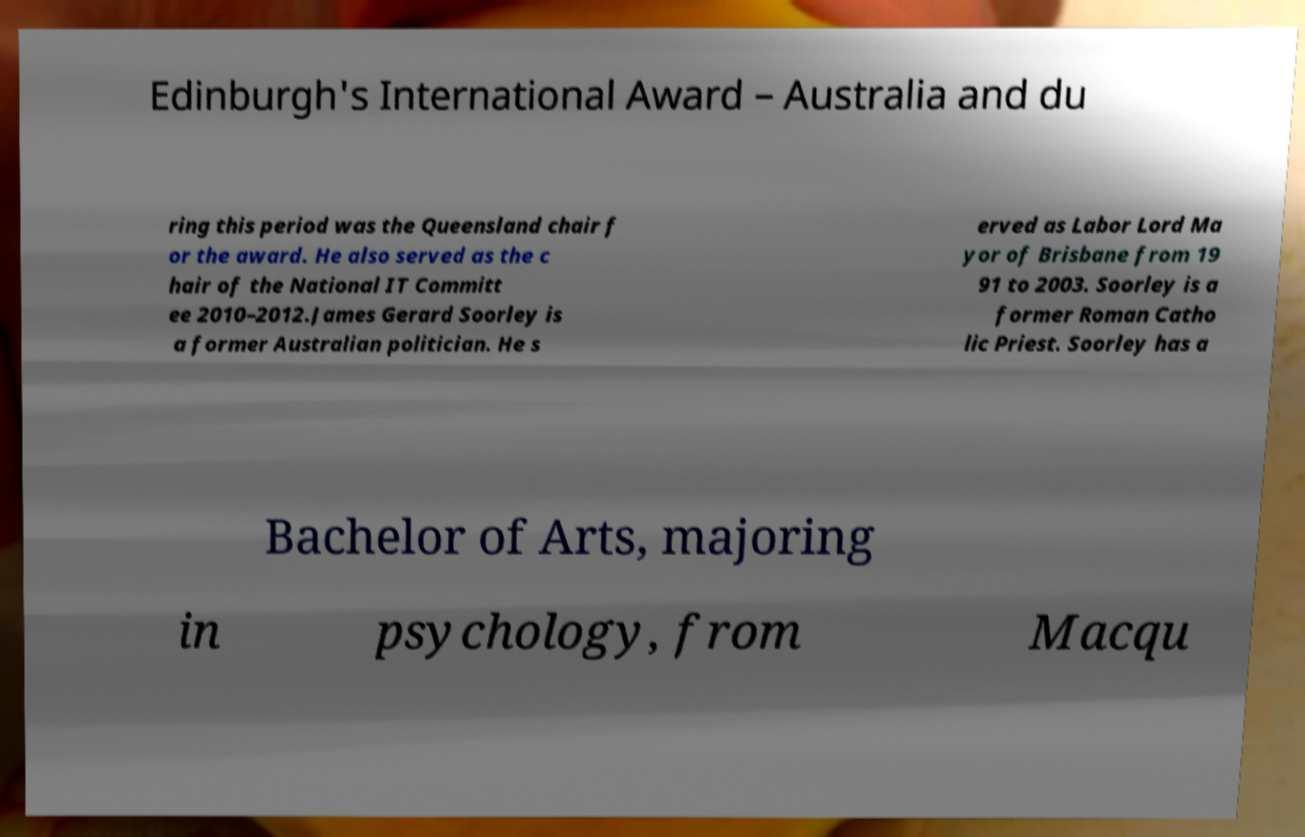Can you accurately transcribe the text from the provided image for me? Edinburgh's International Award – Australia and du ring this period was the Queensland chair f or the award. He also served as the c hair of the National IT Committ ee 2010–2012.James Gerard Soorley is a former Australian politician. He s erved as Labor Lord Ma yor of Brisbane from 19 91 to 2003. Soorley is a former Roman Catho lic Priest. Soorley has a Bachelor of Arts, majoring in psychology, from Macqu 